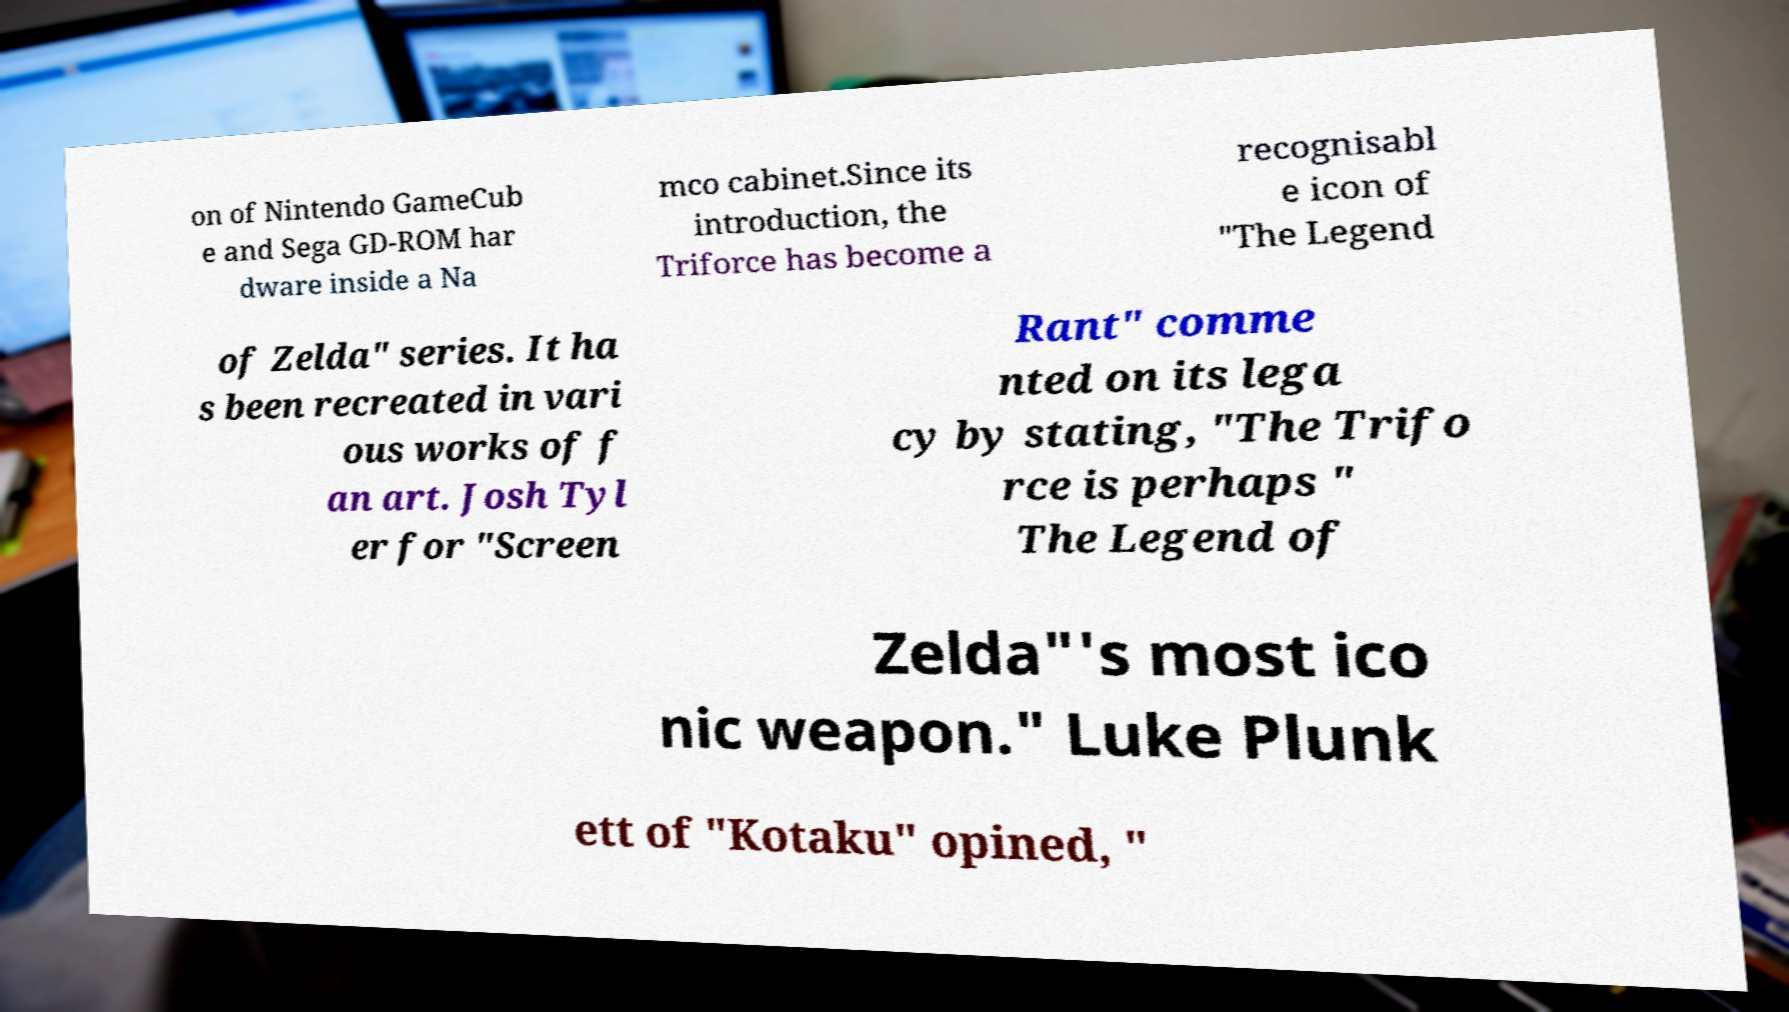Can you read and provide the text displayed in the image?This photo seems to have some interesting text. Can you extract and type it out for me? on of Nintendo GameCub e and Sega GD-ROM har dware inside a Na mco cabinet.Since its introduction, the Triforce has become a recognisabl e icon of "The Legend of Zelda" series. It ha s been recreated in vari ous works of f an art. Josh Tyl er for "Screen Rant" comme nted on its lega cy by stating, "The Trifo rce is perhaps " The Legend of Zelda"'s most ico nic weapon." Luke Plunk ett of "Kotaku" opined, " 